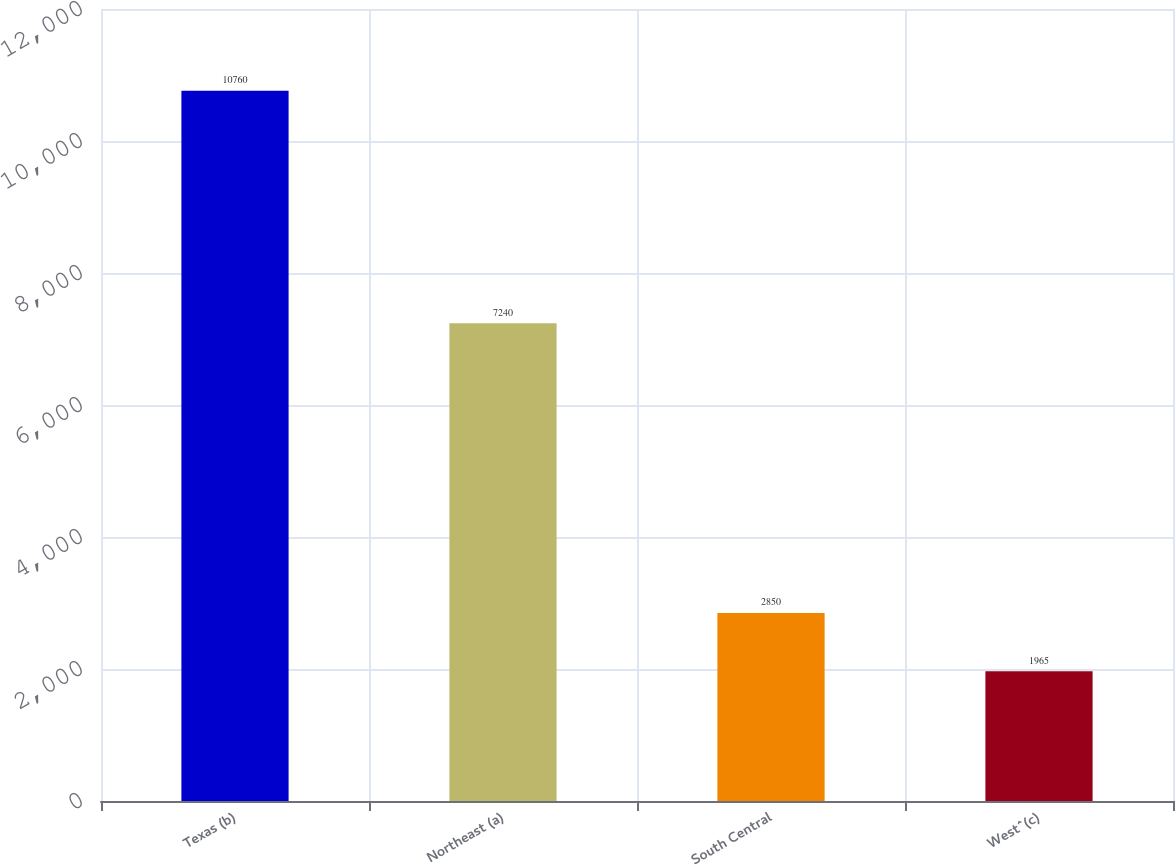Convert chart to OTSL. <chart><loc_0><loc_0><loc_500><loc_500><bar_chart><fcel>Texas (b)<fcel>Northeast (a)<fcel>South Central<fcel>West^(c)<nl><fcel>10760<fcel>7240<fcel>2850<fcel>1965<nl></chart> 